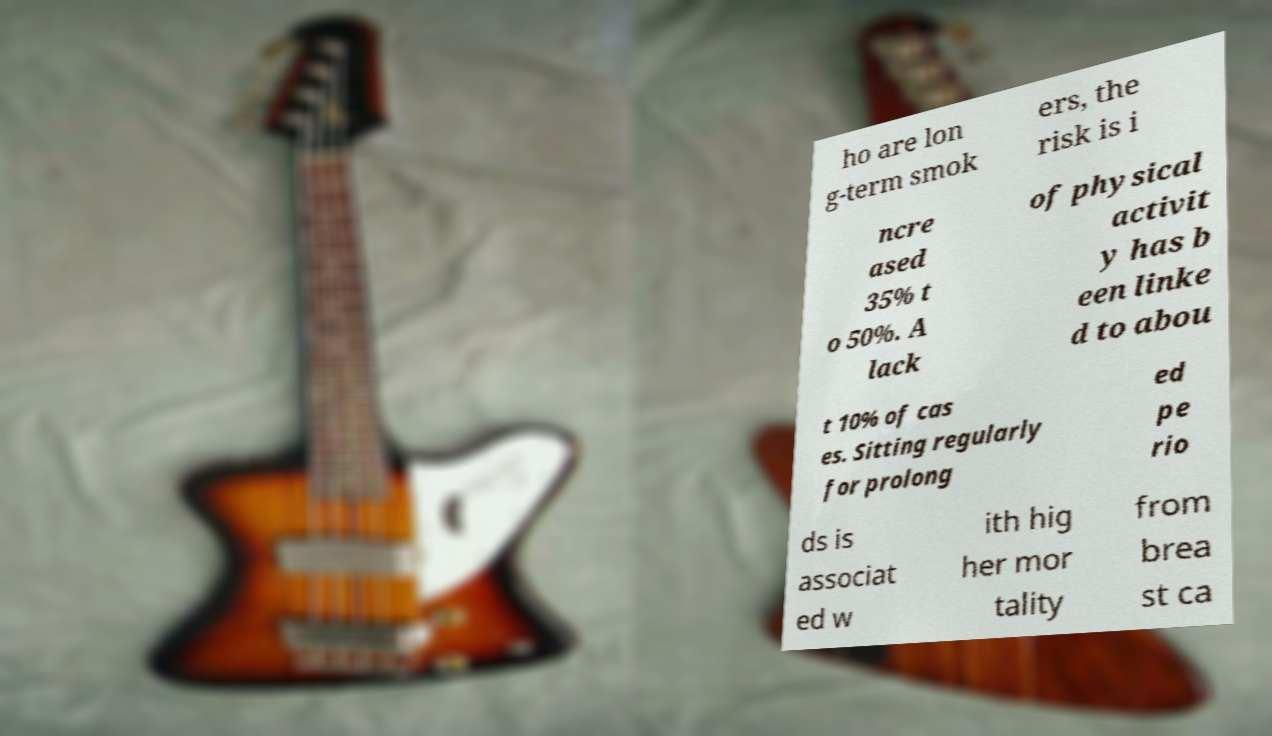Could you assist in decoding the text presented in this image and type it out clearly? ho are lon g-term smok ers, the risk is i ncre ased 35% t o 50%. A lack of physical activit y has b een linke d to abou t 10% of cas es. Sitting regularly for prolong ed pe rio ds is associat ed w ith hig her mor tality from brea st ca 